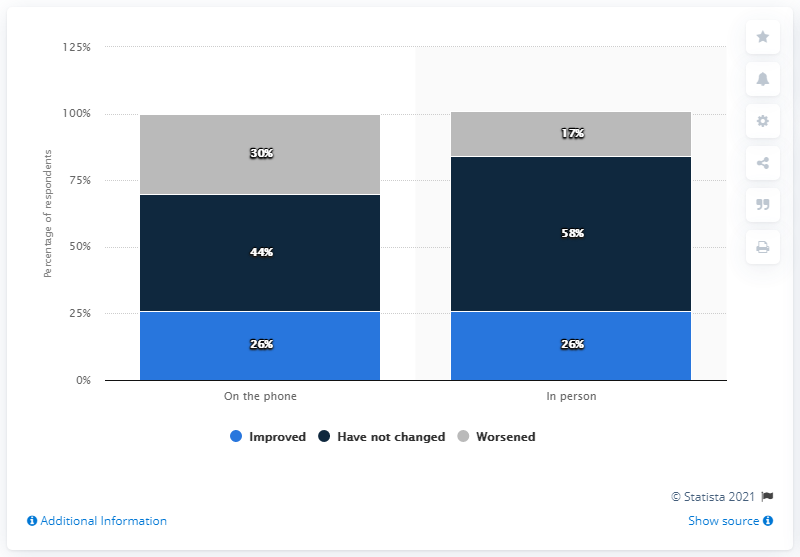List a handful of essential elements in this visual. In the chart, 44% of respondents stated that customer service has not changed. The average score for "Improved" versus "Have not changed" in the "In Person" category is 51. 